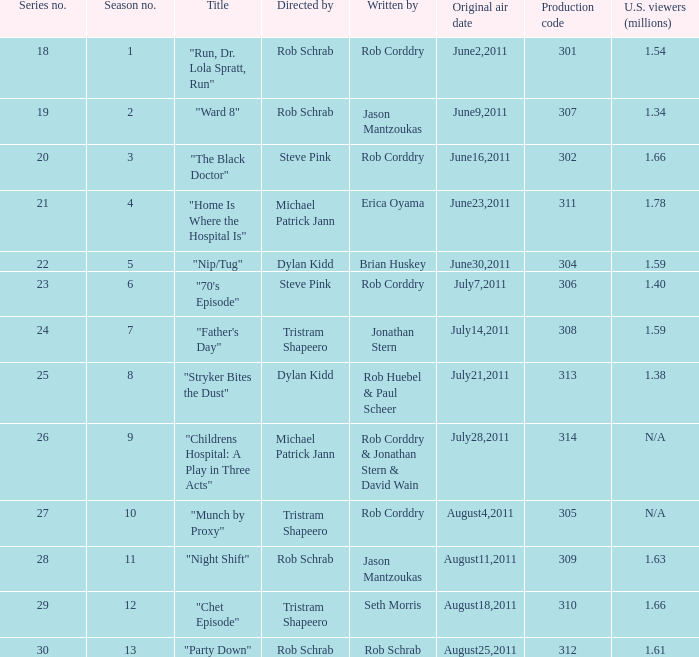In the series, what was the numerical order of the episode called "ward 8"? 19.0. 